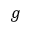<formula> <loc_0><loc_0><loc_500><loc_500>g</formula> 